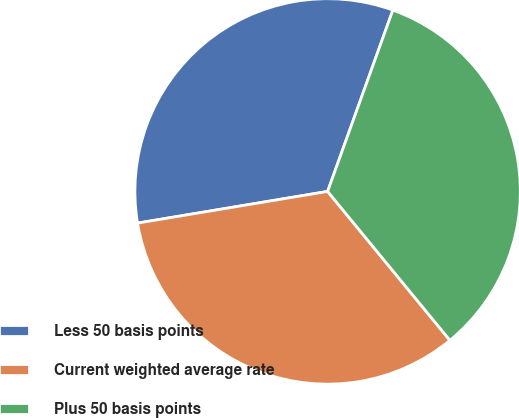Convert chart. <chart><loc_0><loc_0><loc_500><loc_500><pie_chart><fcel>Less 50 basis points<fcel>Current weighted average rate<fcel>Plus 50 basis points<nl><fcel>33.13%<fcel>33.32%<fcel>33.56%<nl></chart> 